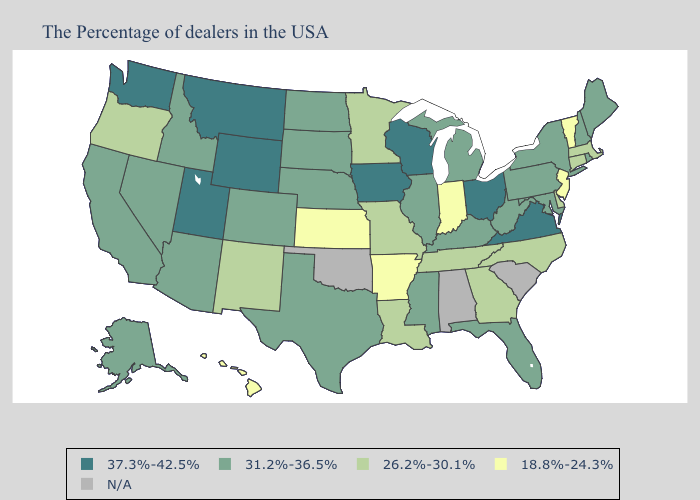What is the value of Ohio?
Short answer required. 37.3%-42.5%. What is the highest value in the South ?
Short answer required. 37.3%-42.5%. Name the states that have a value in the range N/A?
Write a very short answer. South Carolina, Alabama, Oklahoma. Does Montana have the lowest value in the West?
Give a very brief answer. No. Among the states that border Tennessee , which have the highest value?
Write a very short answer. Virginia. What is the value of New Mexico?
Give a very brief answer. 26.2%-30.1%. Which states have the lowest value in the MidWest?
Give a very brief answer. Indiana, Kansas. What is the value of Alabama?
Quick response, please. N/A. Does the first symbol in the legend represent the smallest category?
Give a very brief answer. No. Name the states that have a value in the range N/A?
Keep it brief. South Carolina, Alabama, Oklahoma. Does Arkansas have the lowest value in the South?
Answer briefly. Yes. What is the value of Delaware?
Be succinct. 26.2%-30.1%. Name the states that have a value in the range 31.2%-36.5%?
Quick response, please. Maine, Rhode Island, New Hampshire, New York, Maryland, Pennsylvania, West Virginia, Florida, Michigan, Kentucky, Illinois, Mississippi, Nebraska, Texas, South Dakota, North Dakota, Colorado, Arizona, Idaho, Nevada, California, Alaska. What is the value of Maine?
Give a very brief answer. 31.2%-36.5%. What is the lowest value in states that border Utah?
Short answer required. 26.2%-30.1%. 